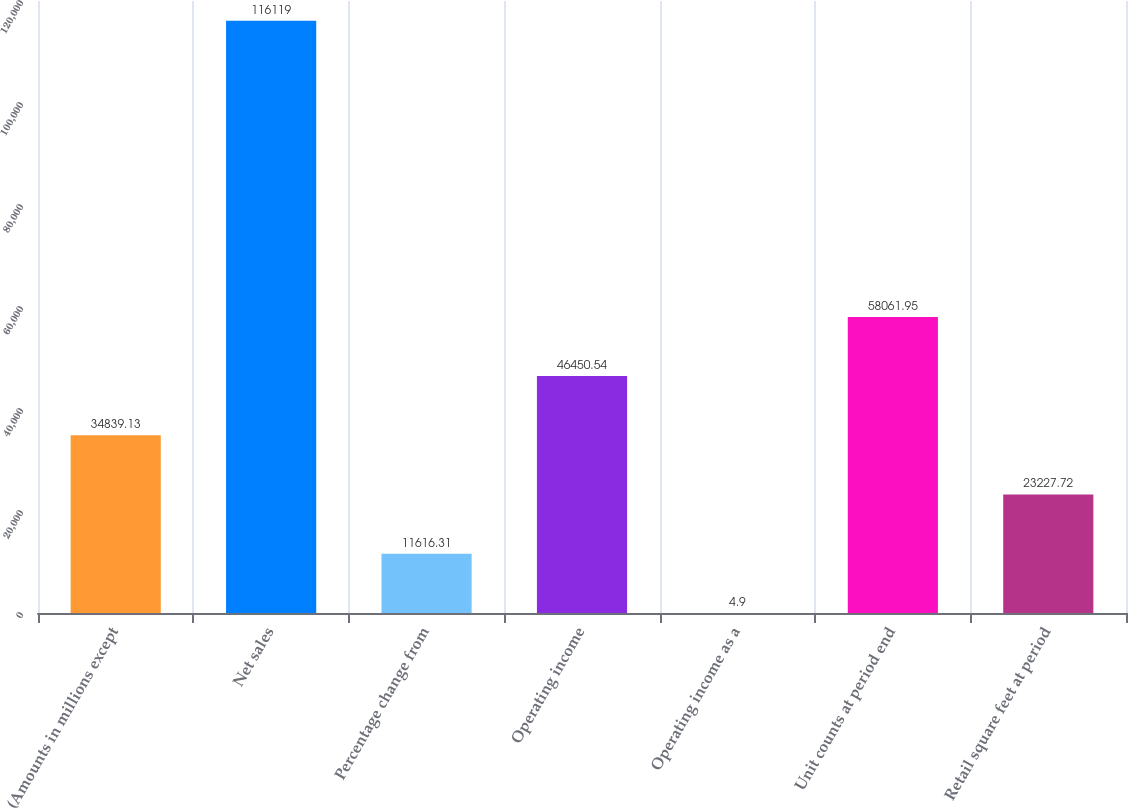Convert chart to OTSL. <chart><loc_0><loc_0><loc_500><loc_500><bar_chart><fcel>(Amounts in millions except<fcel>Net sales<fcel>Percentage change from<fcel>Operating income<fcel>Operating income as a<fcel>Unit counts at period end<fcel>Retail square feet at period<nl><fcel>34839.1<fcel>116119<fcel>11616.3<fcel>46450.5<fcel>4.9<fcel>58061.9<fcel>23227.7<nl></chart> 